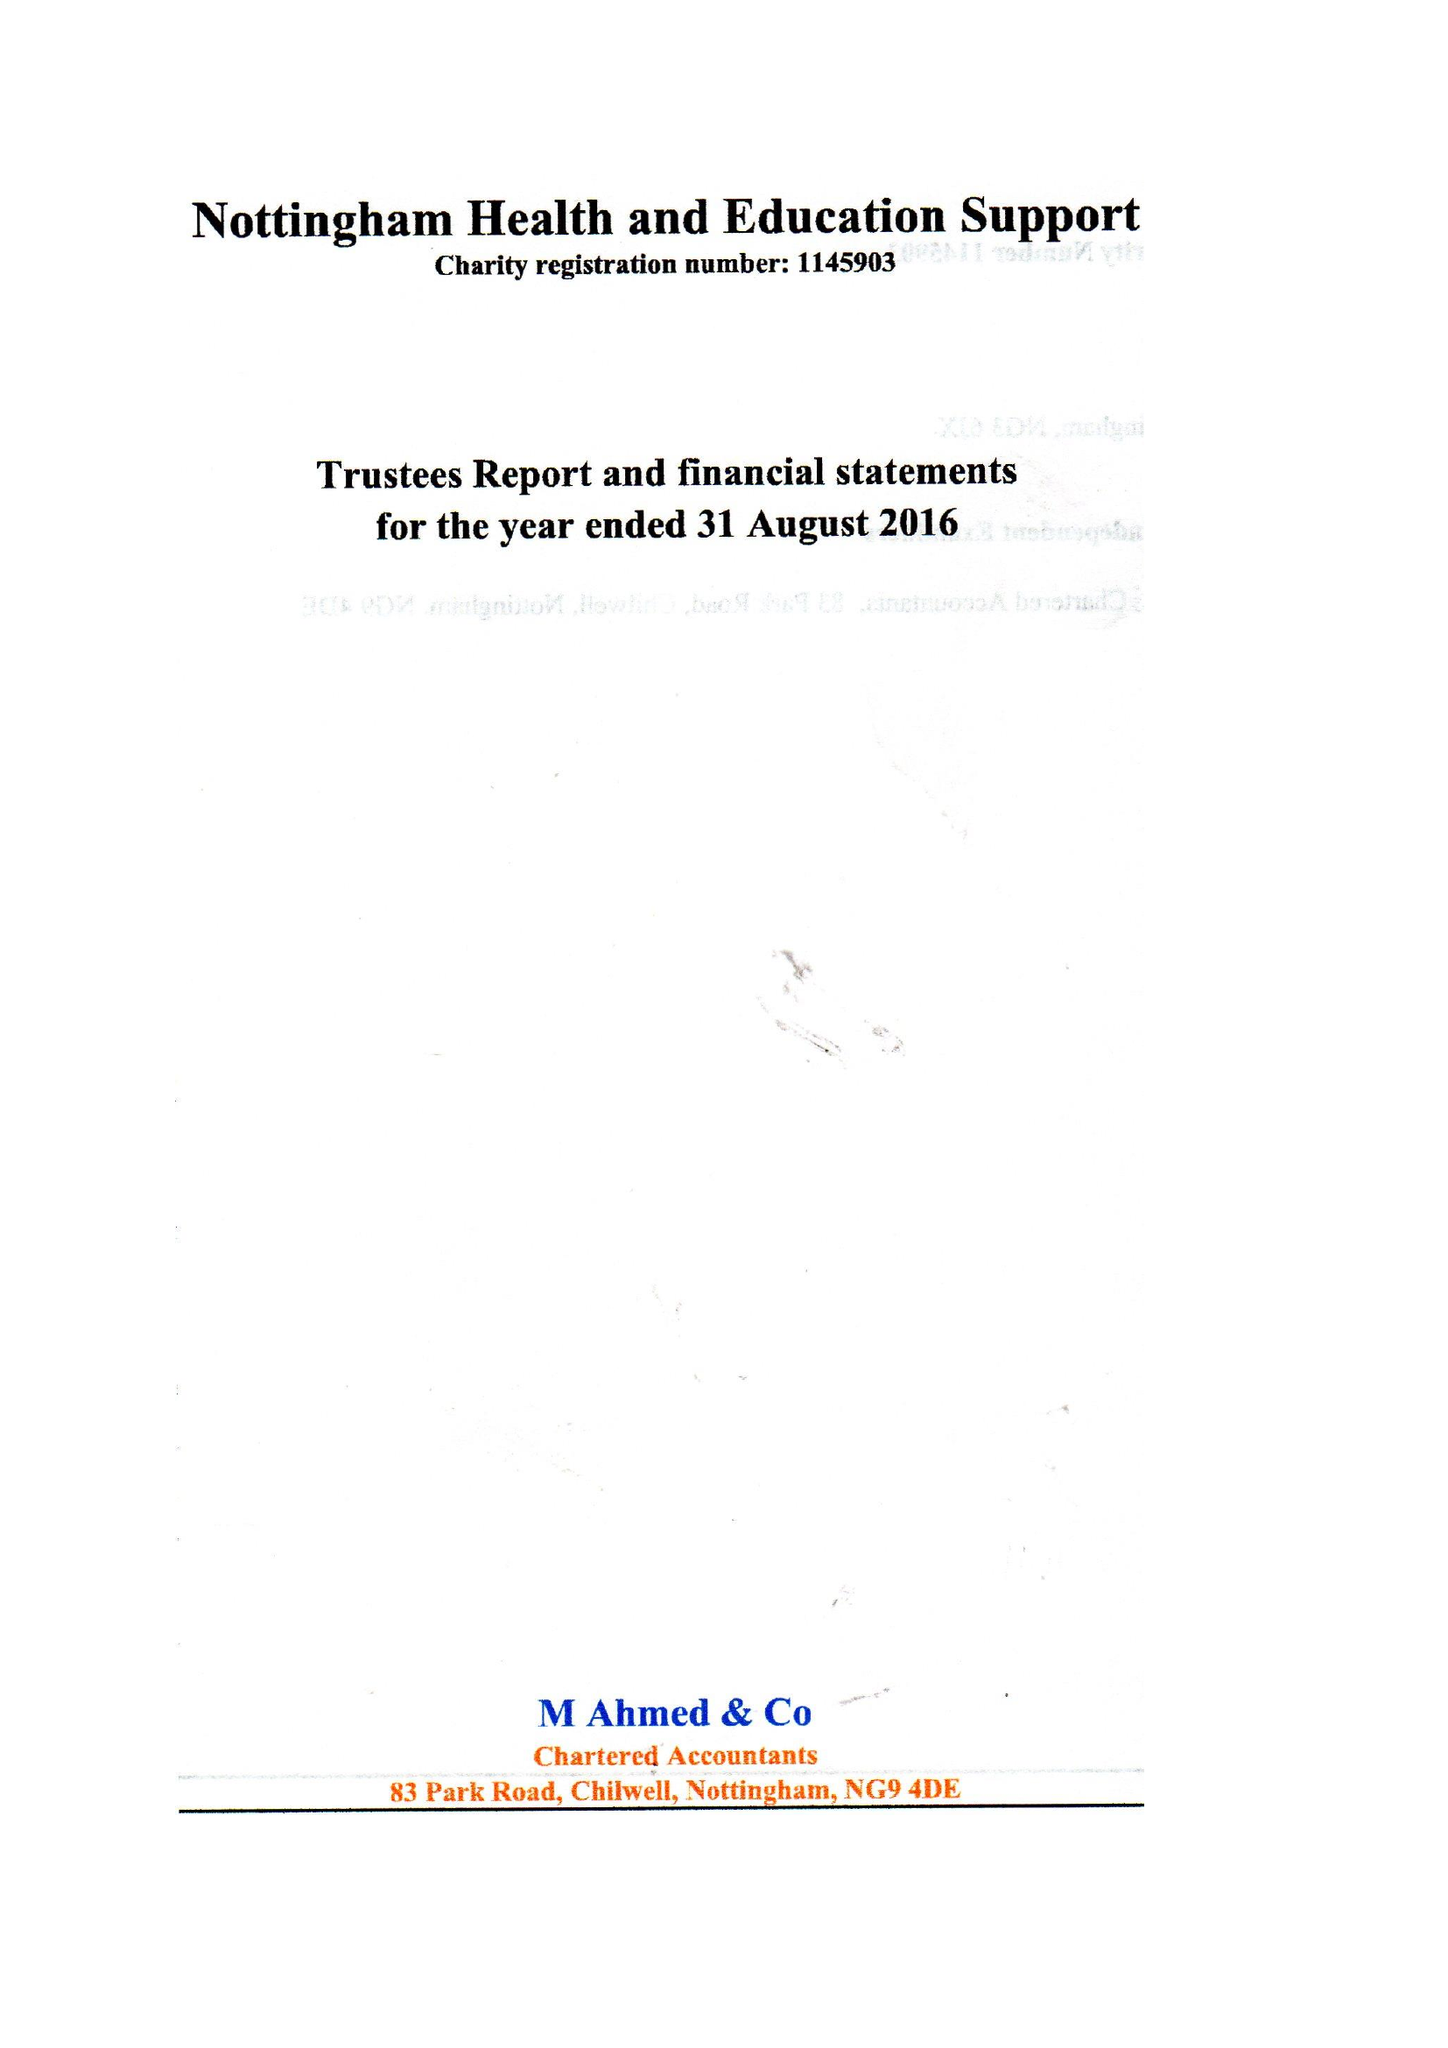What is the value for the address__post_town?
Answer the question using a single word or phrase. NOTTINGHAM 